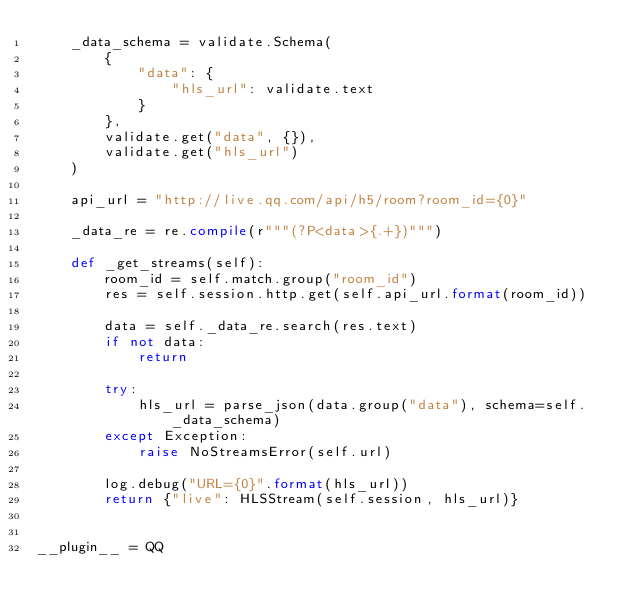<code> <loc_0><loc_0><loc_500><loc_500><_Python_>    _data_schema = validate.Schema(
        {
            "data": {
                "hls_url": validate.text
            }
        },
        validate.get("data", {}),
        validate.get("hls_url")
    )

    api_url = "http://live.qq.com/api/h5/room?room_id={0}"

    _data_re = re.compile(r"""(?P<data>{.+})""")

    def _get_streams(self):
        room_id = self.match.group("room_id")
        res = self.session.http.get(self.api_url.format(room_id))

        data = self._data_re.search(res.text)
        if not data:
            return

        try:
            hls_url = parse_json(data.group("data"), schema=self._data_schema)
        except Exception:
            raise NoStreamsError(self.url)

        log.debug("URL={0}".format(hls_url))
        return {"live": HLSStream(self.session, hls_url)}


__plugin__ = QQ
</code> 